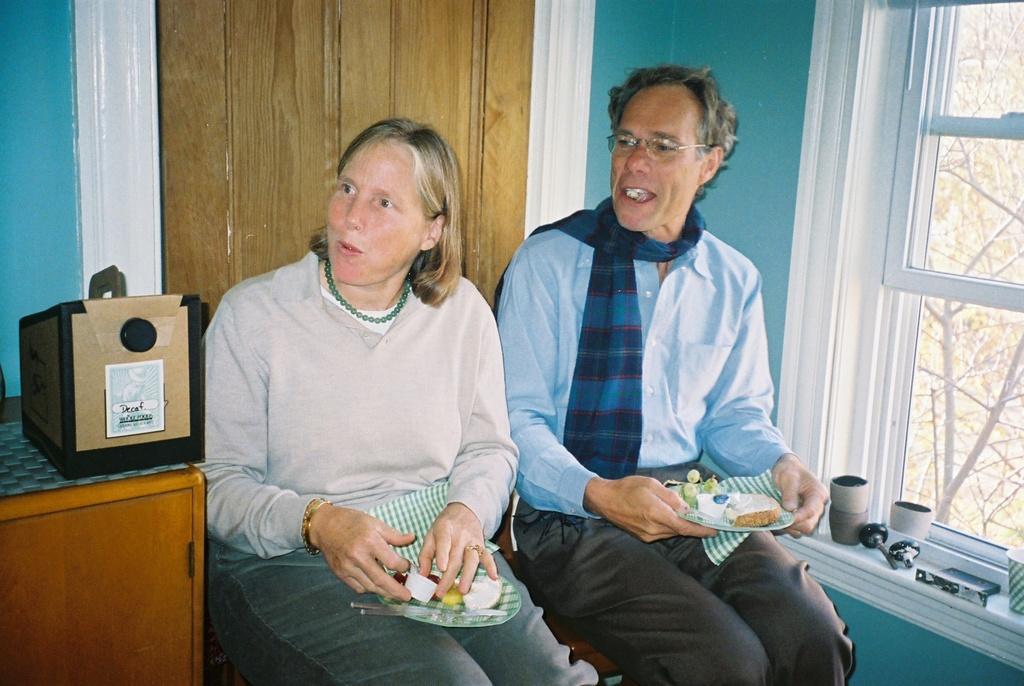Could you give a brief overview of what you see in this image? In this image there are two persons sitting on the table and holding plates, on the plates there are some food items, there is a box on the table, a door, few objects near the window and outside the window there are few trees. 